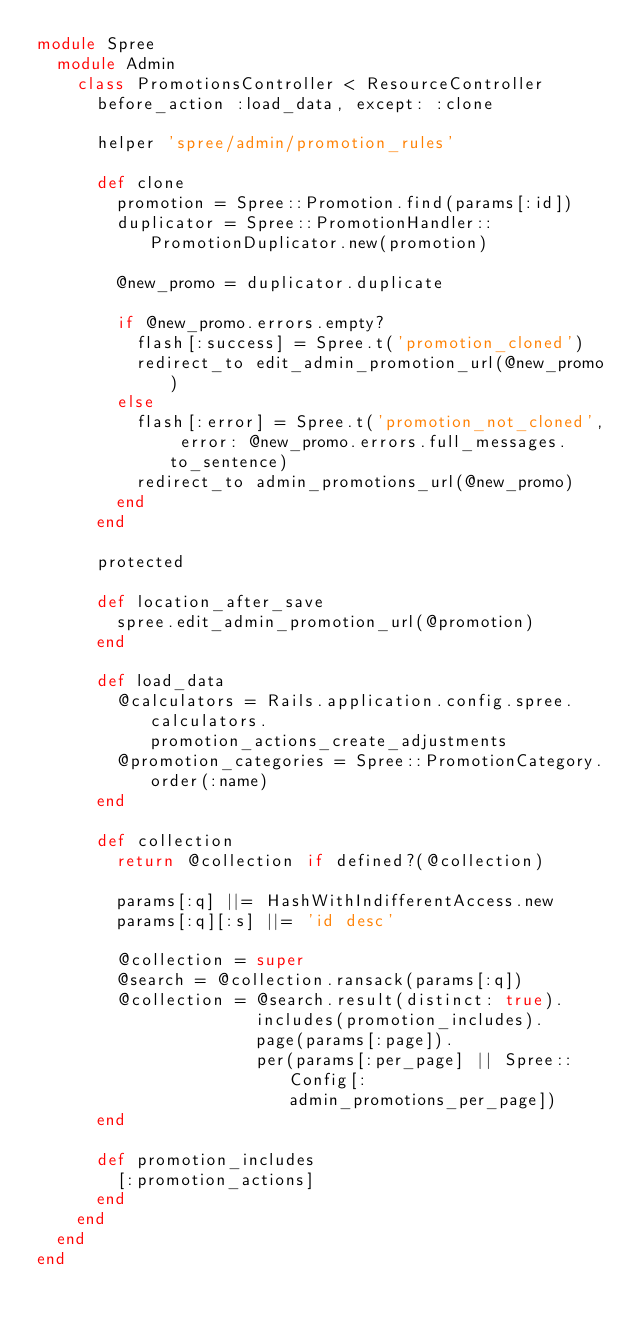Convert code to text. <code><loc_0><loc_0><loc_500><loc_500><_Ruby_>module Spree
  module Admin
    class PromotionsController < ResourceController
      before_action :load_data, except: :clone

      helper 'spree/admin/promotion_rules'

      def clone
        promotion = Spree::Promotion.find(params[:id])
        duplicator = Spree::PromotionHandler::PromotionDuplicator.new(promotion)

        @new_promo = duplicator.duplicate

        if @new_promo.errors.empty?
          flash[:success] = Spree.t('promotion_cloned')
          redirect_to edit_admin_promotion_url(@new_promo)
        else
          flash[:error] = Spree.t('promotion_not_cloned', error: @new_promo.errors.full_messages.to_sentence)
          redirect_to admin_promotions_url(@new_promo)
        end
      end

      protected

      def location_after_save
        spree.edit_admin_promotion_url(@promotion)
      end

      def load_data
        @calculators = Rails.application.config.spree.calculators.promotion_actions_create_adjustments
        @promotion_categories = Spree::PromotionCategory.order(:name)
      end

      def collection
        return @collection if defined?(@collection)

        params[:q] ||= HashWithIndifferentAccess.new
        params[:q][:s] ||= 'id desc'

        @collection = super
        @search = @collection.ransack(params[:q])
        @collection = @search.result(distinct: true).
                      includes(promotion_includes).
                      page(params[:page]).
                      per(params[:per_page] || Spree::Config[:admin_promotions_per_page])
      end

      def promotion_includes
        [:promotion_actions]
      end
    end
  end
end
</code> 